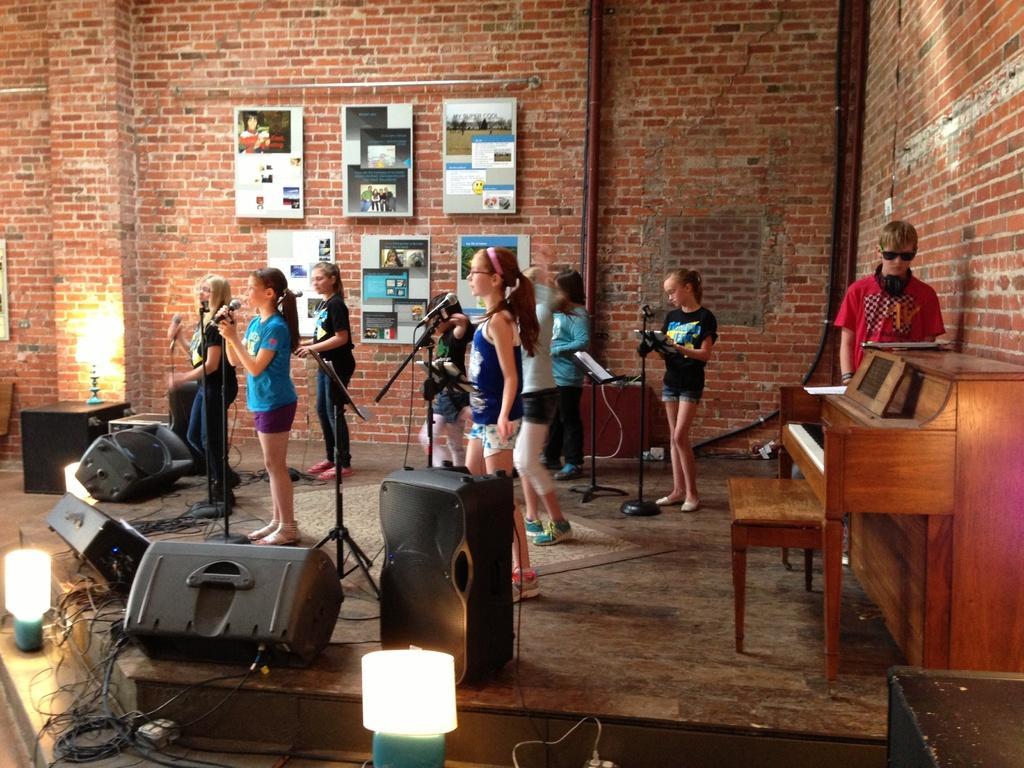Describe this image in one or two sentences. There are group of women standing on a stage and singing on mic. On the right a man is standing at piano board. On the wall we can see frames. On the left there are speakers and lights. 